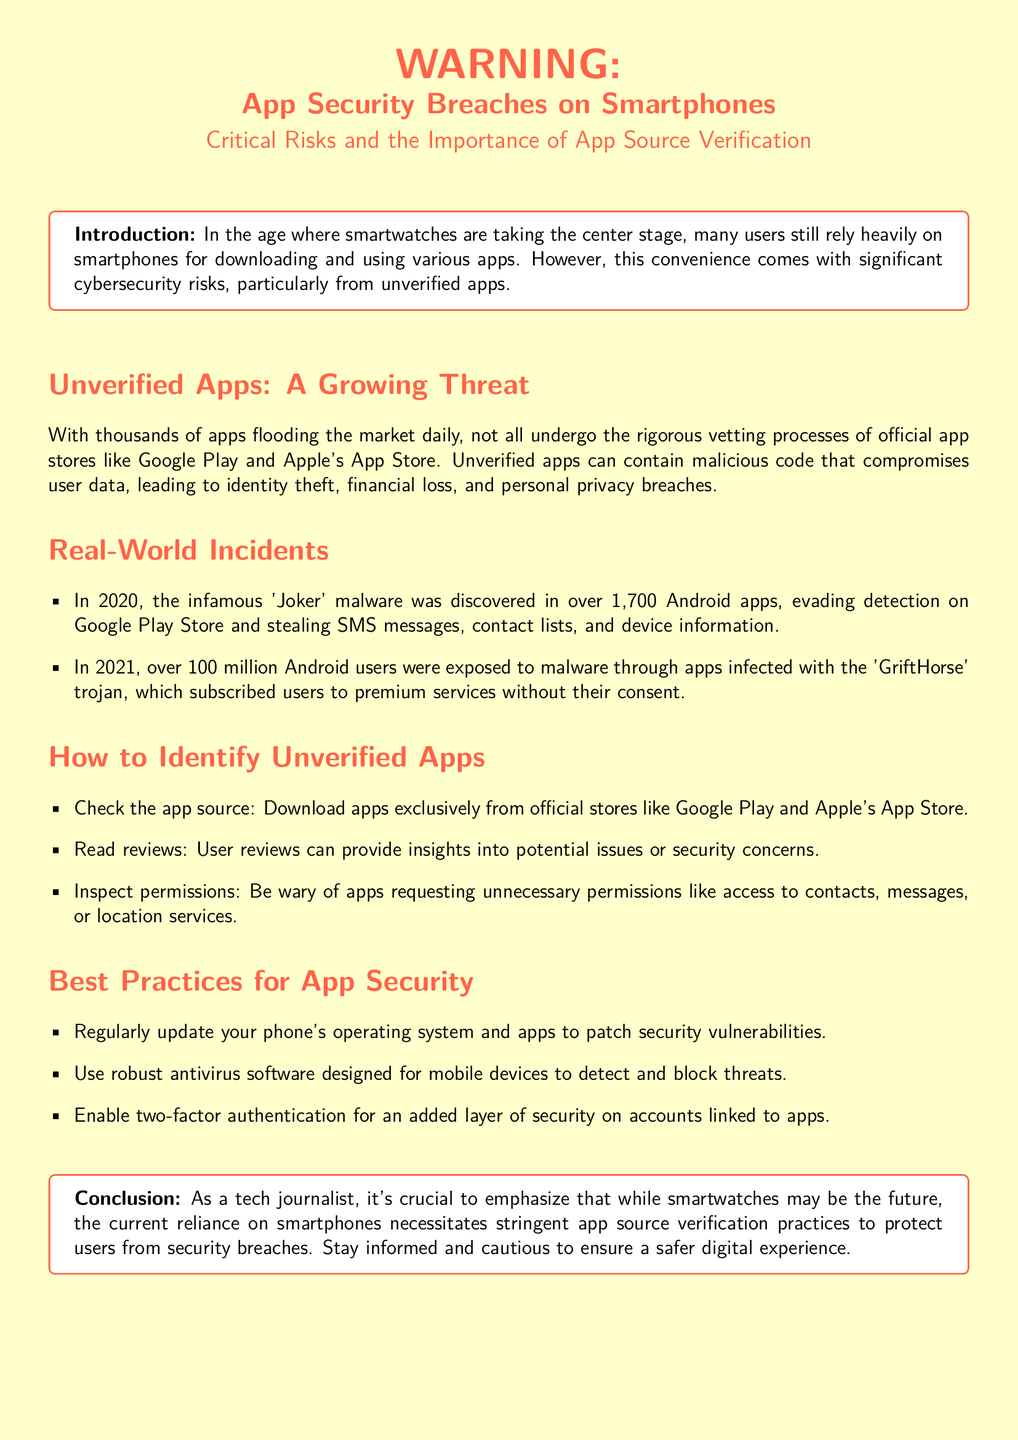What is the title of the document? The title is prominently displayed at the beginning, indicating the main topic of concern regarding app security breaches on smartphones.
Answer: App Security Breaches on Smartphones What year was the 'Joker' malware discovered? The document states a specific incident involving the 'Joker' malware, providing the year of its discovery.
Answer: 2020 How many Android users were affected by the 'GriftHorse' trojan? The document contains details about a security incident that lists the number of affected users, showcasing the scale of the breach.
Answer: 100 million What should users check to identify unverified apps? The document outlines essential actions users can take to avoid security risks, focusing on what they should verify.
Answer: App source What is one best practice for app security mentioned? The document includes a list of recommendations aimed at improving security for app users, summarizing key strategies.
Answer: Regularly update What color is used for warning formatting within the document? The document specifies color choices to highlight critical information, relevant to the warning theme.
Answer: Warning red What does the introduction emphasize regarding smartphone reliance? The document opens by discussing the ongoing use of smartphones and the associated cybersecurity risks, hinting at the broader issue.
Answer: Significant cybersecurity risks What is necessary for protecting users from security breaches according to the conclusion? The conclusion reiterates the need for specific practices to safeguard users, crucial for ensuring digital safety.
Answer: App source verification practices 